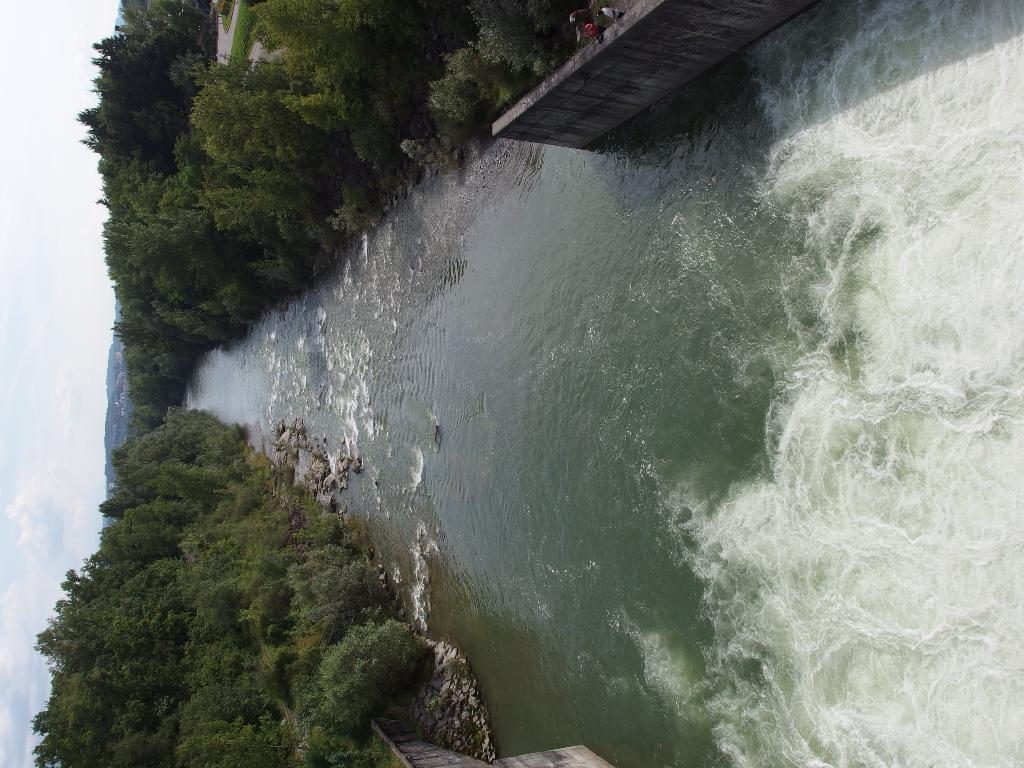What type of natural feature is present in the image? There is a river in the image. What can be seen on the sides of the river? There are trees and rocks on the sides of the river. Is there any man-made structure near the river? Yes, there is a wall on the sides of the river. What part of the sky is visible in the image? The sky is visible on the left side of the image. What type of cake is being served on the riverbank in the image? There is no cake present in the image; it features a river with trees, rocks, and a wall. Can you tell me how many lawyers are standing near the river in the image? There is no lawyer present in the image; it only shows a river, trees, rocks, and a wall. 